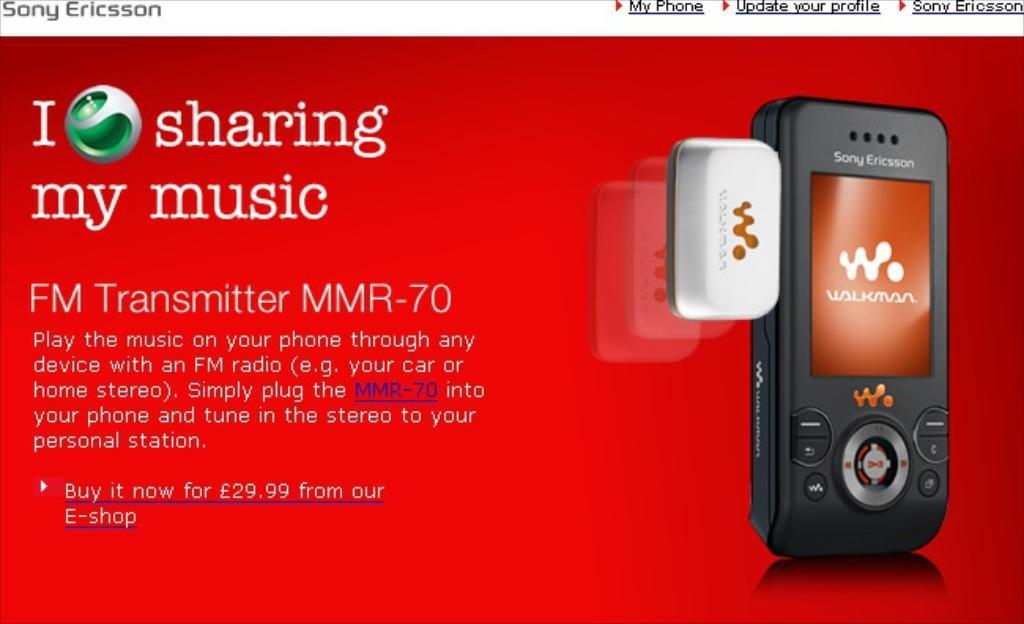<image>
Create a compact narrative representing the image presented. A red advertisement for Sony Ericsson music sharing. 